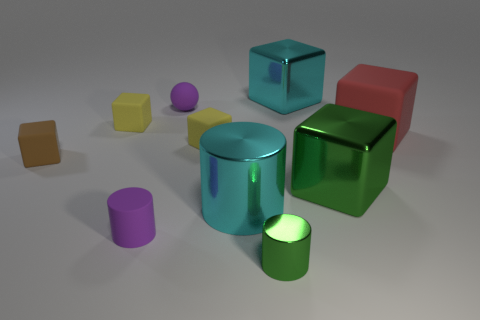Subtract all tiny cylinders. How many cylinders are left? 1 Subtract all red cubes. How many cubes are left? 5 Subtract all cylinders. How many objects are left? 7 Subtract 1 cylinders. How many cylinders are left? 2 Subtract all brown blocks. How many green cylinders are left? 1 Subtract all green cubes. Subtract all big green shiny objects. How many objects are left? 8 Add 5 small cylinders. How many small cylinders are left? 7 Add 1 large cyan shiny things. How many large cyan shiny things exist? 3 Subtract 1 brown blocks. How many objects are left? 9 Subtract all red cylinders. Subtract all blue blocks. How many cylinders are left? 3 